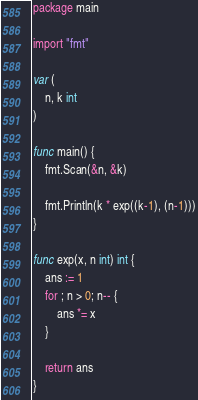Convert code to text. <code><loc_0><loc_0><loc_500><loc_500><_Go_>package main

import "fmt"

var (
	n, k int
)

func main() {
	fmt.Scan(&n, &k)

	fmt.Println(k * exp((k-1), (n-1)))
}

func exp(x, n int) int {
	ans := 1
	for ; n > 0; n-- {
		ans *= x
	}

	return ans
}</code> 